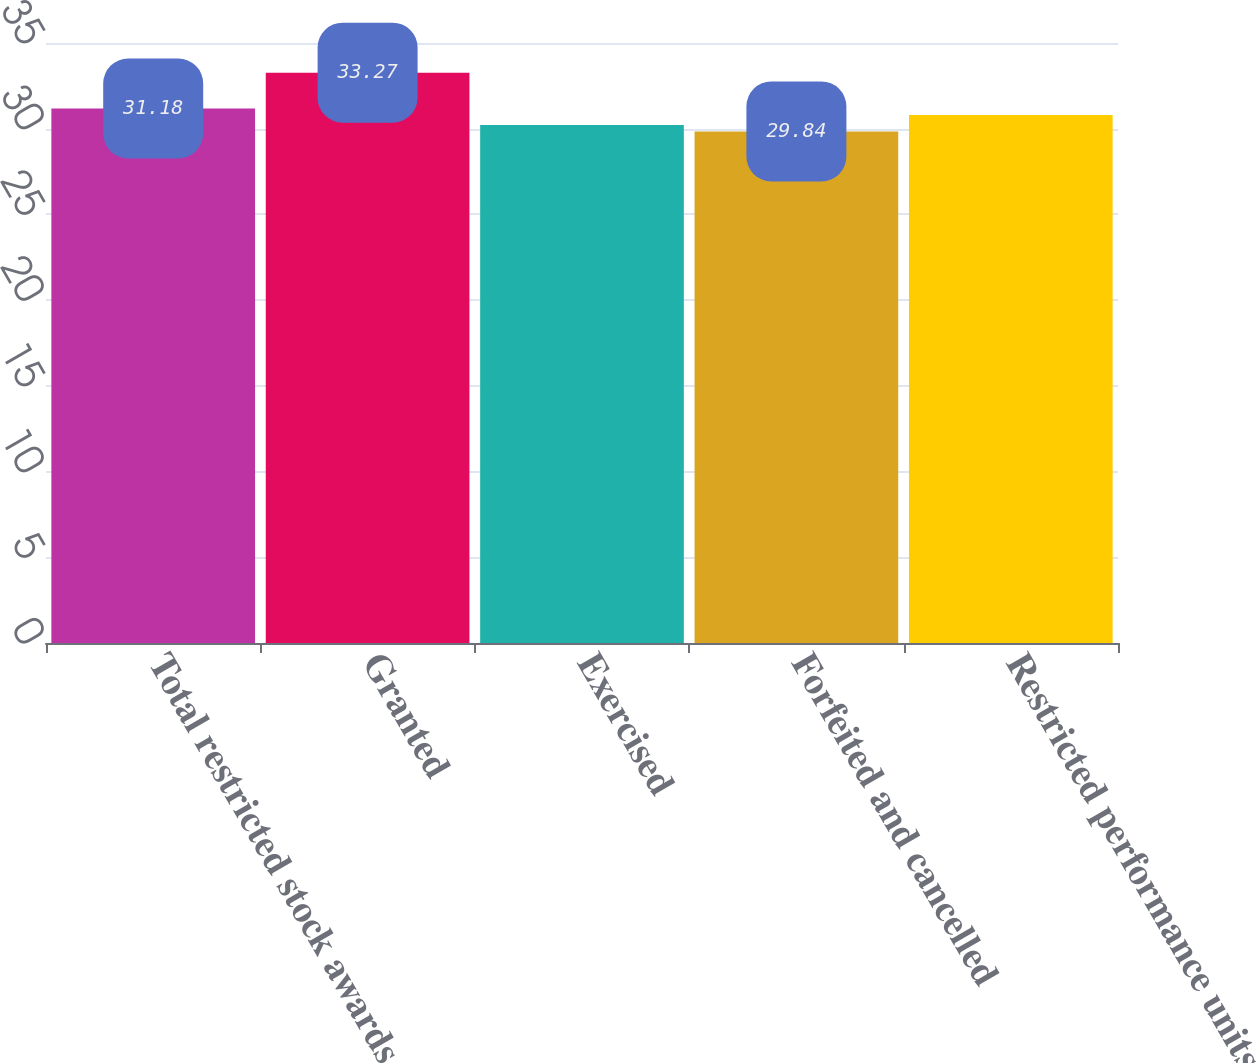Convert chart. <chart><loc_0><loc_0><loc_500><loc_500><bar_chart><fcel>Total restricted stock awards<fcel>Granted<fcel>Exercised<fcel>Forfeited and cancelled<fcel>Restricted performance units<nl><fcel>31.18<fcel>33.27<fcel>30.22<fcel>29.84<fcel>30.8<nl></chart> 